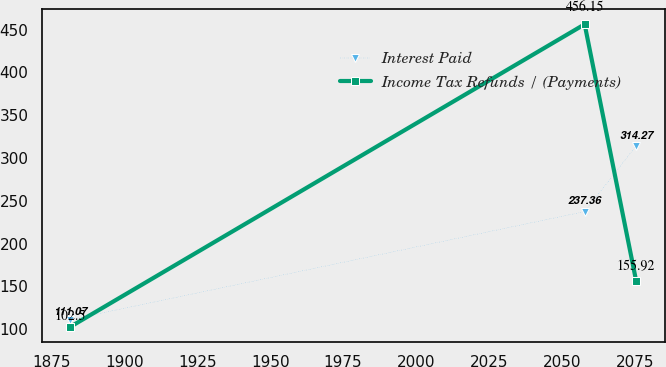<chart> <loc_0><loc_0><loc_500><loc_500><line_chart><ecel><fcel>Interest Paid<fcel>Income Tax Refunds / (Payments)<nl><fcel>1881.4<fcel>111.07<fcel>102.5<nl><fcel>2057.76<fcel>237.36<fcel>456.15<nl><fcel>2075.43<fcel>314.27<fcel>155.92<nl></chart> 